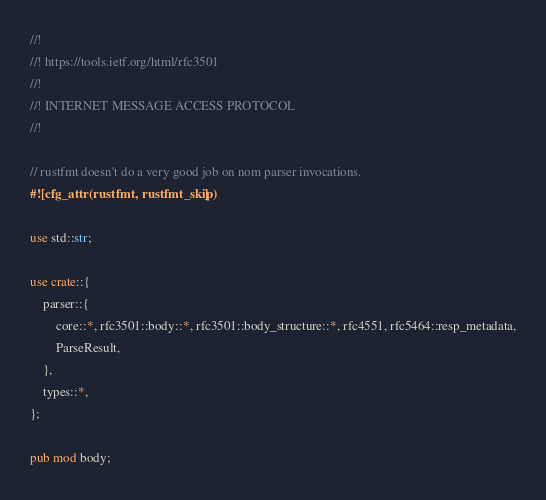<code> <loc_0><loc_0><loc_500><loc_500><_Rust_>//!
//! https://tools.ietf.org/html/rfc3501
//!
//! INTERNET MESSAGE ACCESS PROTOCOL
//!

// rustfmt doesn't do a very good job on nom parser invocations.
#![cfg_attr(rustfmt, rustfmt_skip)]

use std::str;

use crate::{
    parser::{
        core::*, rfc3501::body::*, rfc3501::body_structure::*, rfc4551, rfc5464::resp_metadata,
        ParseResult,
    },
    types::*,
};

pub mod body;</code> 